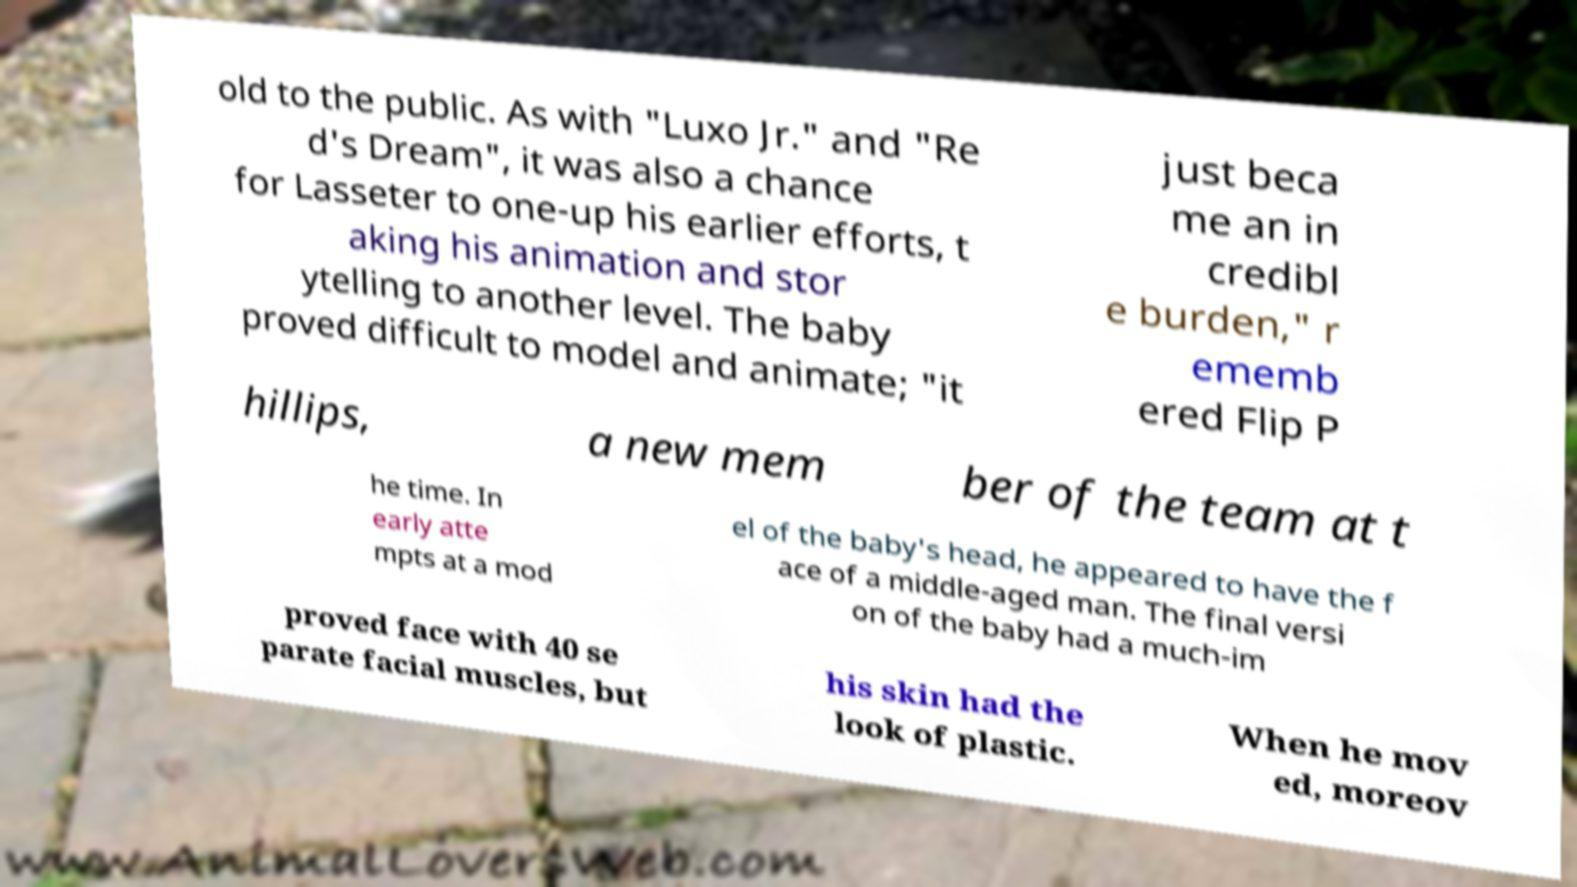Can you read and provide the text displayed in the image?This photo seems to have some interesting text. Can you extract and type it out for me? old to the public. As with "Luxo Jr." and "Re d's Dream", it was also a chance for Lasseter to one-up his earlier efforts, t aking his animation and stor ytelling to another level. The baby proved difficult to model and animate; "it just beca me an in credibl e burden," r ememb ered Flip P hillips, a new mem ber of the team at t he time. In early atte mpts at a mod el of the baby's head, he appeared to have the f ace of a middle-aged man. The final versi on of the baby had a much-im proved face with 40 se parate facial muscles, but his skin had the look of plastic. When he mov ed, moreov 